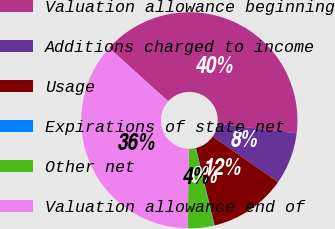Convert chart. <chart><loc_0><loc_0><loc_500><loc_500><pie_chart><fcel>Valuation allowance beginning<fcel>Additions charged to income<fcel>Usage<fcel>Expirations of state net<fcel>Other net<fcel>Valuation allowance end of<nl><fcel>40.25%<fcel>7.75%<fcel>11.57%<fcel>0.09%<fcel>3.92%<fcel>36.42%<nl></chart> 